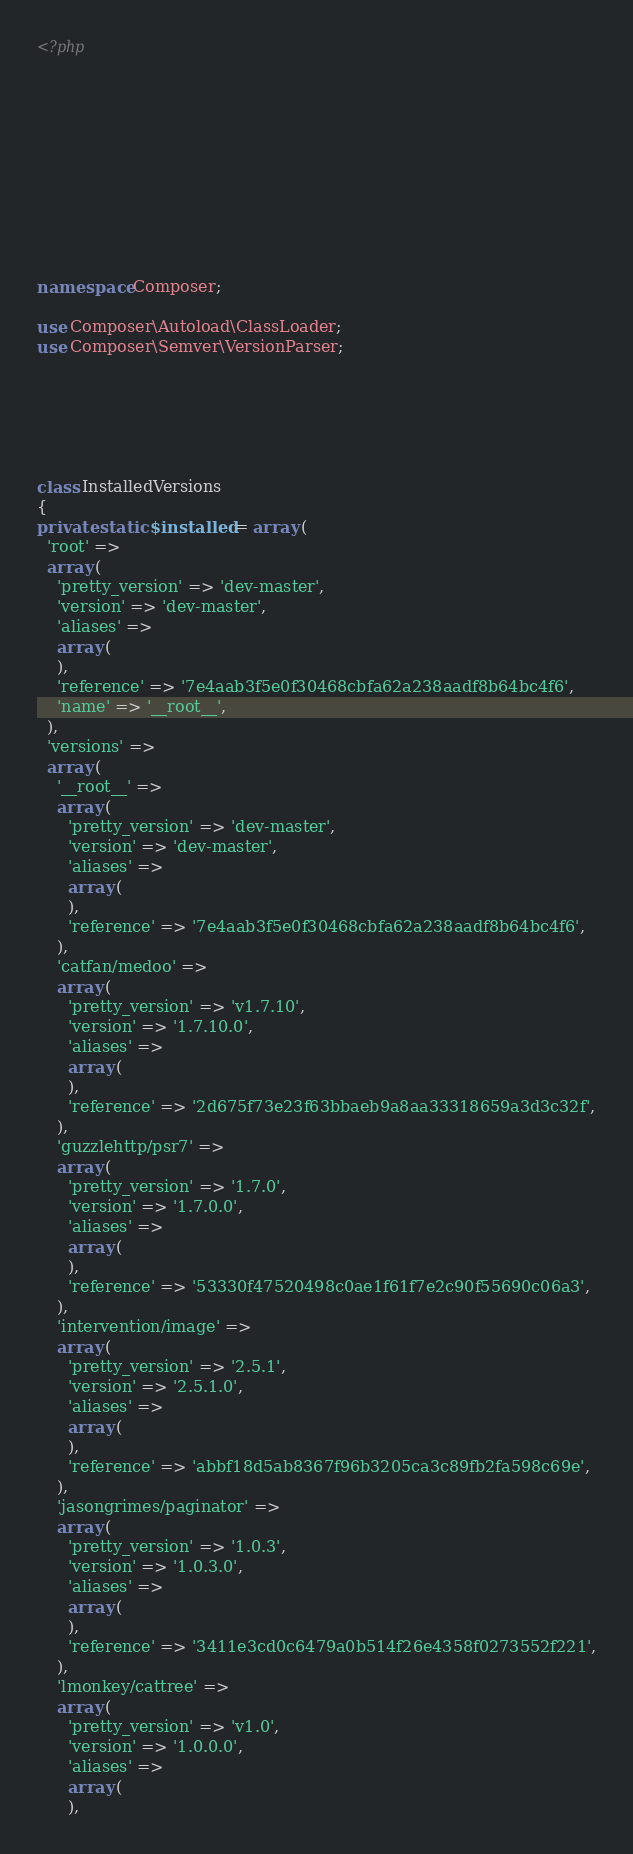<code> <loc_0><loc_0><loc_500><loc_500><_PHP_><?php











namespace Composer;

use Composer\Autoload\ClassLoader;
use Composer\Semver\VersionParser;






class InstalledVersions
{
private static $installed = array (
  'root' => 
  array (
    'pretty_version' => 'dev-master',
    'version' => 'dev-master',
    'aliases' => 
    array (
    ),
    'reference' => '7e4aab3f5e0f30468cbfa62a238aadf8b64bc4f6',
    'name' => '__root__',
  ),
  'versions' => 
  array (
    '__root__' => 
    array (
      'pretty_version' => 'dev-master',
      'version' => 'dev-master',
      'aliases' => 
      array (
      ),
      'reference' => '7e4aab3f5e0f30468cbfa62a238aadf8b64bc4f6',
    ),
    'catfan/medoo' => 
    array (
      'pretty_version' => 'v1.7.10',
      'version' => '1.7.10.0',
      'aliases' => 
      array (
      ),
      'reference' => '2d675f73e23f63bbaeb9a8aa33318659a3d3c32f',
    ),
    'guzzlehttp/psr7' => 
    array (
      'pretty_version' => '1.7.0',
      'version' => '1.7.0.0',
      'aliases' => 
      array (
      ),
      'reference' => '53330f47520498c0ae1f61f7e2c90f55690c06a3',
    ),
    'intervention/image' => 
    array (
      'pretty_version' => '2.5.1',
      'version' => '2.5.1.0',
      'aliases' => 
      array (
      ),
      'reference' => 'abbf18d5ab8367f96b3205ca3c89fb2fa598c69e',
    ),
    'jasongrimes/paginator' => 
    array (
      'pretty_version' => '1.0.3',
      'version' => '1.0.3.0',
      'aliases' => 
      array (
      ),
      'reference' => '3411e3cd0c6479a0b514f26e4358f0273552f221',
    ),
    'lmonkey/cattree' => 
    array (
      'pretty_version' => 'v1.0',
      'version' => '1.0.0.0',
      'aliases' => 
      array (
      ),</code> 